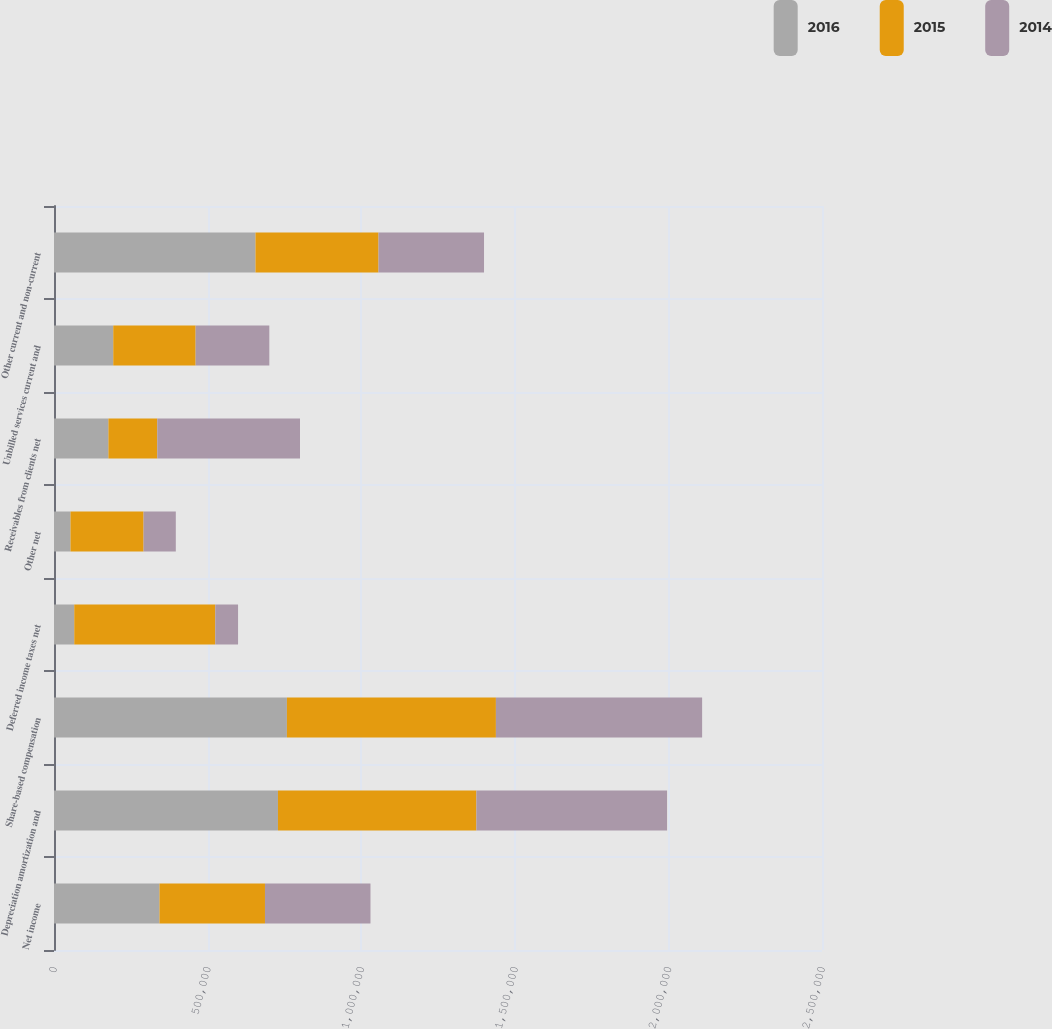Convert chart to OTSL. <chart><loc_0><loc_0><loc_500><loc_500><stacked_bar_chart><ecel><fcel>Net income<fcel>Depreciation amortization and<fcel>Share-based compensation<fcel>Deferred income taxes net<fcel>Other net<fcel>Receivables from clients net<fcel>Unbilled services current and<fcel>Other current and non-current<nl><fcel>2016<fcel>343392<fcel>729052<fcel>758176<fcel>65940<fcel>53706<fcel>177156<fcel>192912<fcel>655876<nl><fcel>2015<fcel>343392<fcel>645923<fcel>680329<fcel>459109<fcel>237876<fcel>158990<fcel>268135<fcel>400524<nl><fcel>2014<fcel>343392<fcel>620743<fcel>671301<fcel>74092<fcel>104950<fcel>464639<fcel>239893<fcel>343392<nl></chart> 